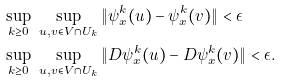Convert formula to latex. <formula><loc_0><loc_0><loc_500><loc_500>& \sup _ { k \geq 0 } \ \sup _ { u , v \in V \cap U _ { k } } \| \psi _ { x } ^ { k } ( u ) - \psi _ { x } ^ { k } ( v ) \| < \epsilon \\ & \sup _ { k \geq 0 } \ \sup _ { u , v \in V \cap U _ { k } } \| D \psi _ { x } ^ { k } ( u ) - D \psi _ { x } ^ { k } ( v ) \| < \epsilon .</formula> 